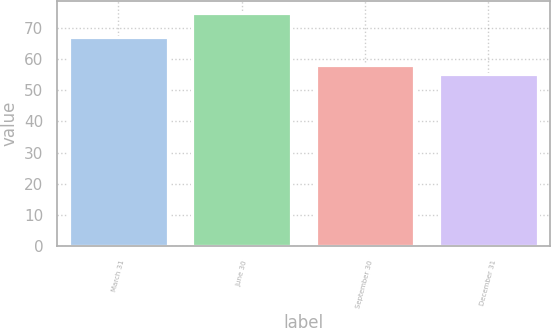Convert chart to OTSL. <chart><loc_0><loc_0><loc_500><loc_500><bar_chart><fcel>March 31<fcel>June 30<fcel>September 30<fcel>December 31<nl><fcel>67.05<fcel>74.72<fcel>58.15<fcel>55.14<nl></chart> 